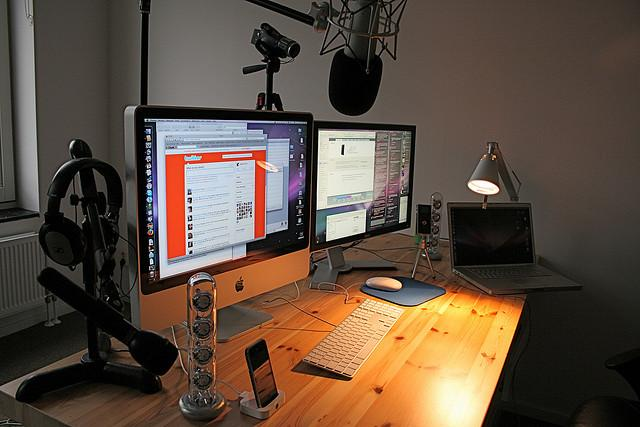What is the wooden item here? desk 